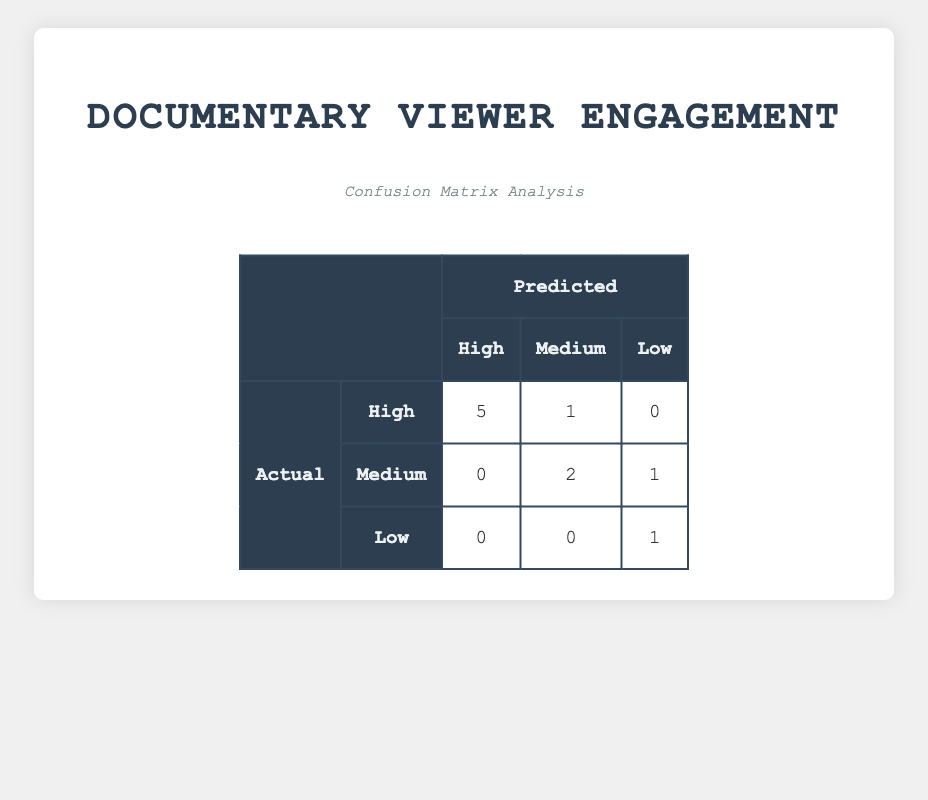What is the predicted count of documentaries with high viewer engagement? According to the table, the predicted count for "High" viewer engagement is represented in the first row of the predicted column, which states there are 5 documentaries predicted to have high engagement.
Answer: 5 How many documentaries actually have low viewer engagement? The actual count for "Low" viewer engagement is found in the last row of the actual column, which shows 1 documentary with low engagement.
Answer: 1 What is the total number of documentaries in the "Medium" viewer engagement category? To find this, we can look at the total counts for documentaries in the "Actual" column, which shows 3 documentaries for "Medium" engagement as well as 3 for "Predicted" which are listed in the table.
Answer: 3 Is the actual number of documentaries with high viewer engagement equal to the predicted number? To determine this, we compare the actual count of 6 with the predicted count of 5. Since 6 does not equal 5, the statement is false.
Answer: No What is the difference between the actual and predicted counts of documentaries with medium viewer engagement? The actual count for "Medium" is 3 and the predicted count is also 3. The difference is calculated by subtracting the predicted from the actual: 3 - 3 = 0.
Answer: 0 How many documentaries were predicted to have low viewer engagement? The predicted count for low engagement is found in the last column of the second row, which states that 2 documentaries were predicted to have low engagement.
Answer: 2 What percentage of the predicted documentaries show high viewer engagement compared to the total number? The predicted count for high engagement is 5 out of the total predicted of 10 (5 high + 3 medium + 2 low = 10). The percentage is calculated by (5/10) * 100 = 50%.
Answer: 50% How many documentaries actually received high engagement but were predicted to have medium engagement? To find this, we look at the "actual" column for high engagement which has a count of 6, and check "Medium" in the predicted column which states there are 3. There were no documentaries actually rated high that fall into the medium predicted category, so this answer is zero.
Answer: 0 Which category had the highest discrepancy between actual and predicted values? To determine this, we look at the differences: for high: 6 (actual) - 5 (predicted) = 1, for medium: 3 - 3 = 0, and for low: 1 - 2 = -1. The highest discrepancy is 1 for high viewer engagement.
Answer: High 